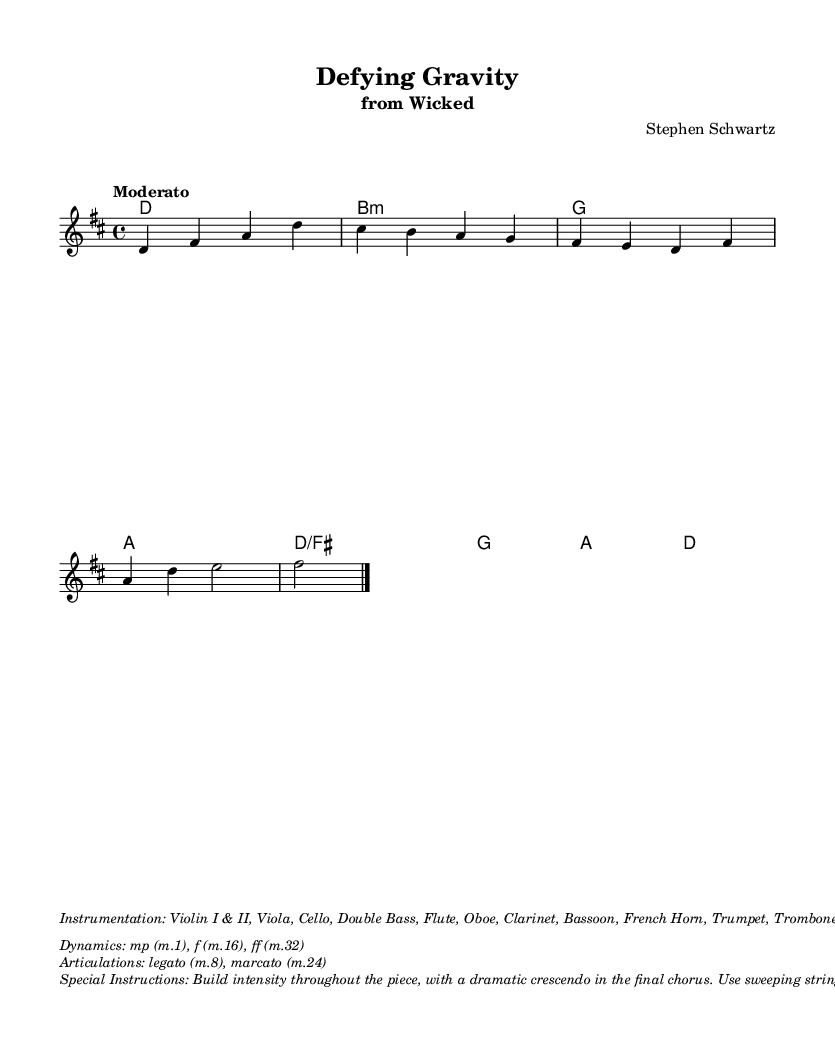What is the key signature of this music? The key signature is indicated at the beginning of the score and shows two sharps, which correspond to D major.
Answer: D major What is the time signature of this piece? The time signature is shown at the beginning of the score and indicates that the music is set in a 4/4 time, meaning there are four beats in each measure.
Answer: 4/4 What is the tempo of the piece? The tempo is marked in the score, indicating that the music should be played at a "Moderato" pace, which typically suggests a moderate speed.
Answer: Moderato What is the instrumentation for this arrangement? The instrumentation is listed in the markup section and specifies the various instruments used in the symphonic arrangement, such as strings, woodwinds, brass, and percussion.
Answer: Violin I & II, Viola, Cello, Double Bass, Flute, Oboe, Clarinet, Bassoon, French Horn, Trumpet, Trombone, Timpani, Percussion, Harp, Piano What dynamics are specified in the sheet music? Dynamics are provided in the markup section, outlining whether sections should be played at mezzo-piano (mp), forte (f), or fortissimo (ff) at different points in the piece.
Answer: mp, f, ff How should the intensity be built throughout the piece? The special instructions indicate that the intensity should be incrementally increased, culminating in a dramatic crescendo during the final chorus, highlighting the emotional build-up in the performance.
Answer: Build intensity throughout the piece What articulations are instructed in the music? Articulations are noted in the markup section, specifically indicating that certain sections should be played legato or marcato, guiding the performers on how to express the musical lines.
Answer: legato, marcato 